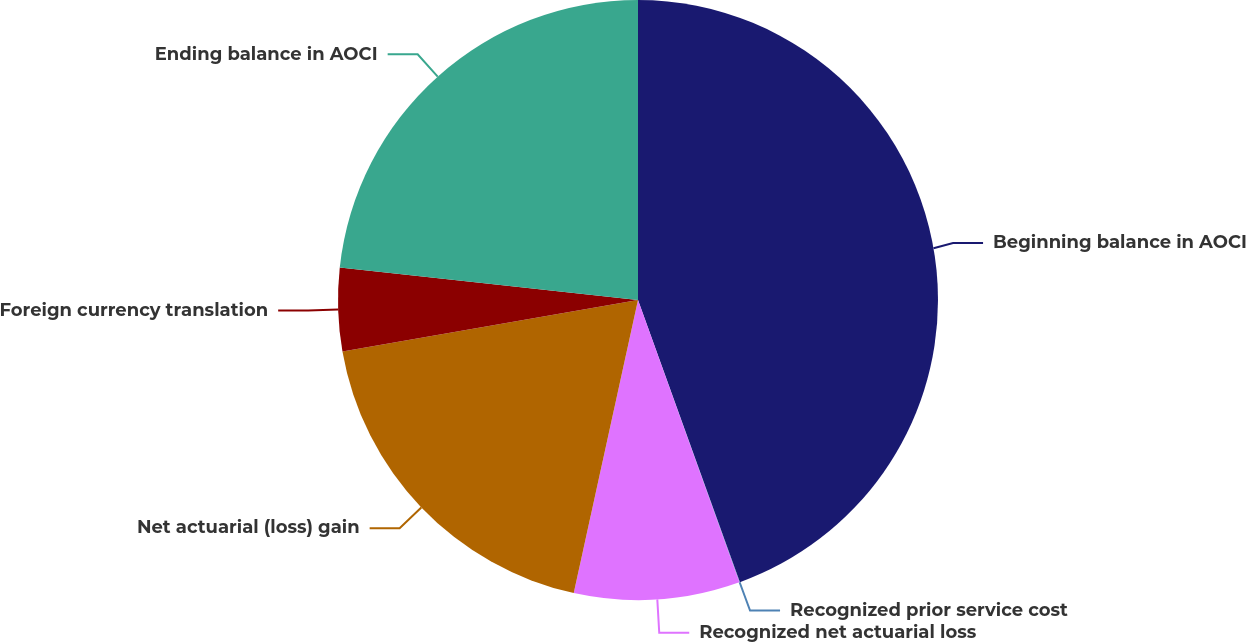Convert chart to OTSL. <chart><loc_0><loc_0><loc_500><loc_500><pie_chart><fcel>Beginning balance in AOCI<fcel>Recognized prior service cost<fcel>Recognized net actuarial loss<fcel>Net actuarial (loss) gain<fcel>Foreign currency translation<fcel>Ending balance in AOCI<nl><fcel>44.48%<fcel>0.03%<fcel>8.92%<fcel>18.82%<fcel>4.47%<fcel>23.27%<nl></chart> 